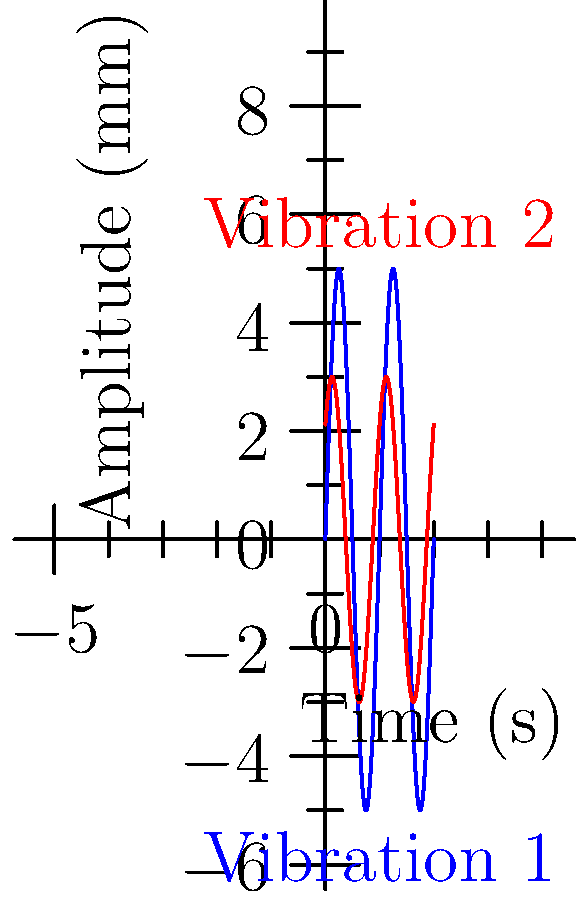A mineral sorting machine exhibits two distinct vibrational patterns as shown in the graph. Vibration 1 (blue) is described by the equation $y_1 = 5\sin(2\pi t)$ mm, while Vibration 2 (red) is described by $y_2 = 3\sin(2\pi t + \frac{\pi}{4})$ mm, where $t$ is time in seconds. What is the maximum absolute difference in amplitude between these two vibrations at any given time? To find the maximum absolute difference in amplitude, we need to follow these steps:

1) The amplitudes of the two vibrations are:
   Vibration 1: $A_1 = 5$ mm
   Vibration 2: $A_2 = 3$ mm

2) The maximum possible amplitude for each vibration occurs when the sine function equals 1 or -1:
   Max amplitude for Vibration 1: $\pm 5$ mm
   Max amplitude for Vibration 2: $\pm 3$ mm

3) The maximum difference will occur when one vibration is at its maximum positive amplitude and the other is at its maximum negative amplitude.

4) Calculate the difference:
   $|5 - (-3)| = |5 + 3| = |8| = 8$ mm
   or
   $|-5 - 3| = |-8| = 8$ mm

5) Therefore, the maximum absolute difference in amplitude is 8 mm.

Note: The phase difference ($\frac{\pi}{4}$) doesn't affect the maximum amplitude difference, only when it occurs in the cycle.
Answer: 8 mm 